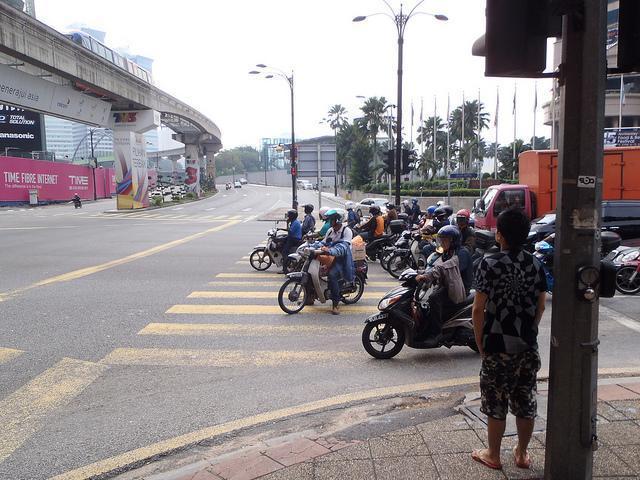How many people are in the picture?
Give a very brief answer. 2. How many motorcycles are there?
Give a very brief answer. 2. 